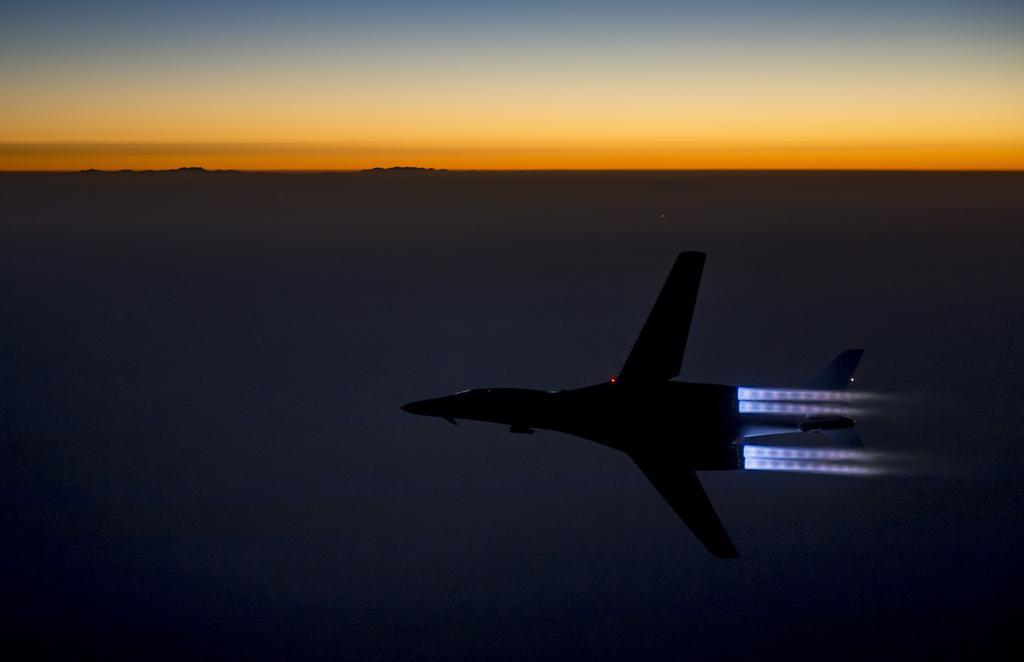Could you give a brief overview of what you see in this image? In this picture we can see a jet plane in the air. 